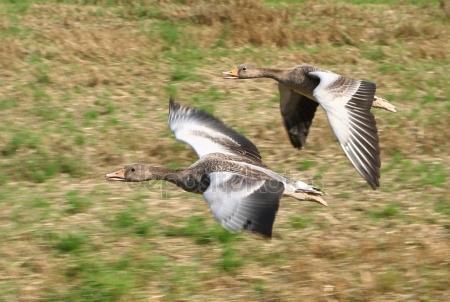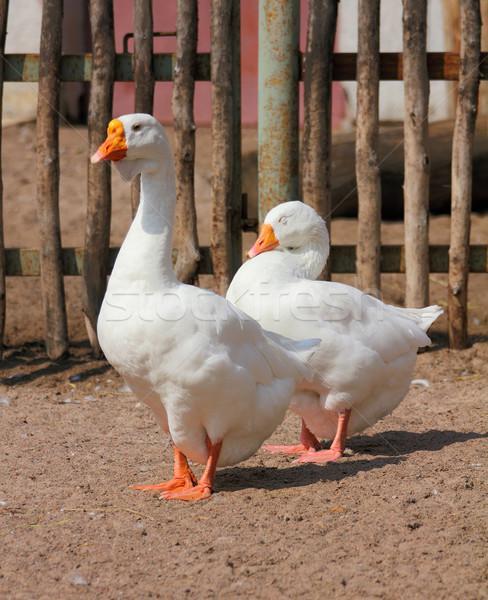The first image is the image on the left, the second image is the image on the right. For the images displayed, is the sentence "The birds in the image on the right are near a body of water." factually correct? Answer yes or no. No. The first image is the image on the left, the second image is the image on the right. For the images displayed, is the sentence "At least one image includes two birds standing face to face on dry land in the foreground." factually correct? Answer yes or no. No. 